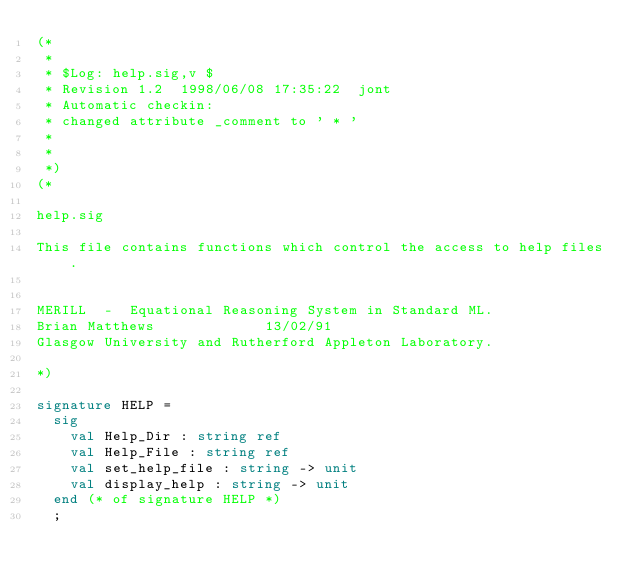Convert code to text. <code><loc_0><loc_0><loc_500><loc_500><_SML_>(*
 *
 * $Log: help.sig,v $
 * Revision 1.2  1998/06/08 17:35:22  jont
 * Automatic checkin:
 * changed attribute _comment to ' * '
 *
 *
 *)
(*

help.sig

This file contains functions which control the access to help files.


MERILL  -  Equational Reasoning System in Standard ML.
Brian Matthews				     13/02/91
Glasgow University and Rutherford Appleton Laboratory.

*)

signature HELP = 
  sig
    val Help_Dir : string ref
    val Help_File : string ref
    val set_help_file : string -> unit
    val display_help : string -> unit
  end (* of signature HELP *)
  ;
</code> 